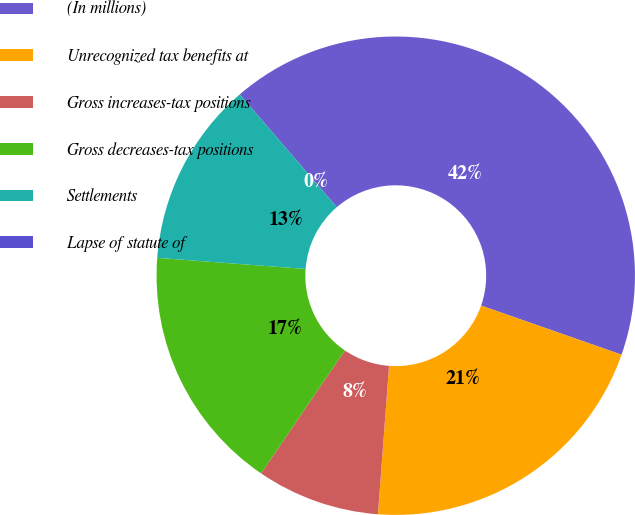Convert chart. <chart><loc_0><loc_0><loc_500><loc_500><pie_chart><fcel>(In millions)<fcel>Unrecognized tax benefits at<fcel>Gross increases-tax positions<fcel>Gross decreases-tax positions<fcel>Settlements<fcel>Lapse of statute of<nl><fcel>41.66%<fcel>20.83%<fcel>8.33%<fcel>16.67%<fcel>12.5%<fcel>0.0%<nl></chart> 